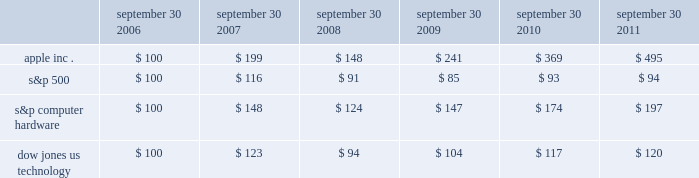Company stock performance the following graph shows a five-year comparison of cumulative total shareholder return , calculated on a dividend reinvested basis , for the company , the s&p 500 composite index , the s&p computer hardware index , and the dow jones u.s .
Technology index .
The graph assumes $ 100 was invested in each of the company 2019s common stock , the s&p 500 composite index , the s&p computer hardware index , and the dow jones u.s .
Technology index on september 30 , 2006 .
Data points on the graph are annual .
Note that historic stock price performance is not necessarily indicative of future stock price performance .
Comparison of 5 year cumulative total return* among apple inc. , the s&p 500 index , the s&p computer hardware index and the dow jones us technology index sep-10sep-09sep-08sep-07sep-06 sep-11 apple inc .
S&p 500 s&p computer hardware dow jones us technology *$ 100 invested on 9/30/06 in stock or index , including reinvestment of dividends .
Fiscal year ending september 30 .
Copyright a9 2011 s&p , a division of the mcgraw-hill companies inc .
All rights reserved .
Copyright a9 2011 dow jones & co .
All rights reserved .
September 30 , september 30 , september 30 , september 30 , september 30 , september 30 .

Did apple achieve a greater return in the year ended sept . 30 2008 than the s&p 500? 
Computations: (148 > 91)
Answer: yes. Company stock performance the following graph shows a five-year comparison of cumulative total shareholder return , calculated on a dividend reinvested basis , for the company , the s&p 500 composite index , the s&p computer hardware index , and the dow jones u.s .
Technology index .
The graph assumes $ 100 was invested in each of the company 2019s common stock , the s&p 500 composite index , the s&p computer hardware index , and the dow jones u.s .
Technology index on september 30 , 2006 .
Data points on the graph are annual .
Note that historic stock price performance is not necessarily indicative of future stock price performance .
Comparison of 5 year cumulative total return* among apple inc. , the s&p 500 index , the s&p computer hardware index and the dow jones us technology index sep-10sep-09sep-08sep-07sep-06 sep-11 apple inc .
S&p 500 s&p computer hardware dow jones us technology *$ 100 invested on 9/30/06 in stock or index , including reinvestment of dividends .
Fiscal year ending september 30 .
Copyright a9 2011 s&p , a division of the mcgraw-hill companies inc .
All rights reserved .
Copyright a9 2011 dow jones & co .
All rights reserved .
September 30 , september 30 , september 30 , september 30 , september 30 , september 30 .

What was the cumulative percentage return for the four years ended september 30 , 2010 for apple inc.? 
Computations: ((369 - 100) / 100)
Answer: 2.69. 